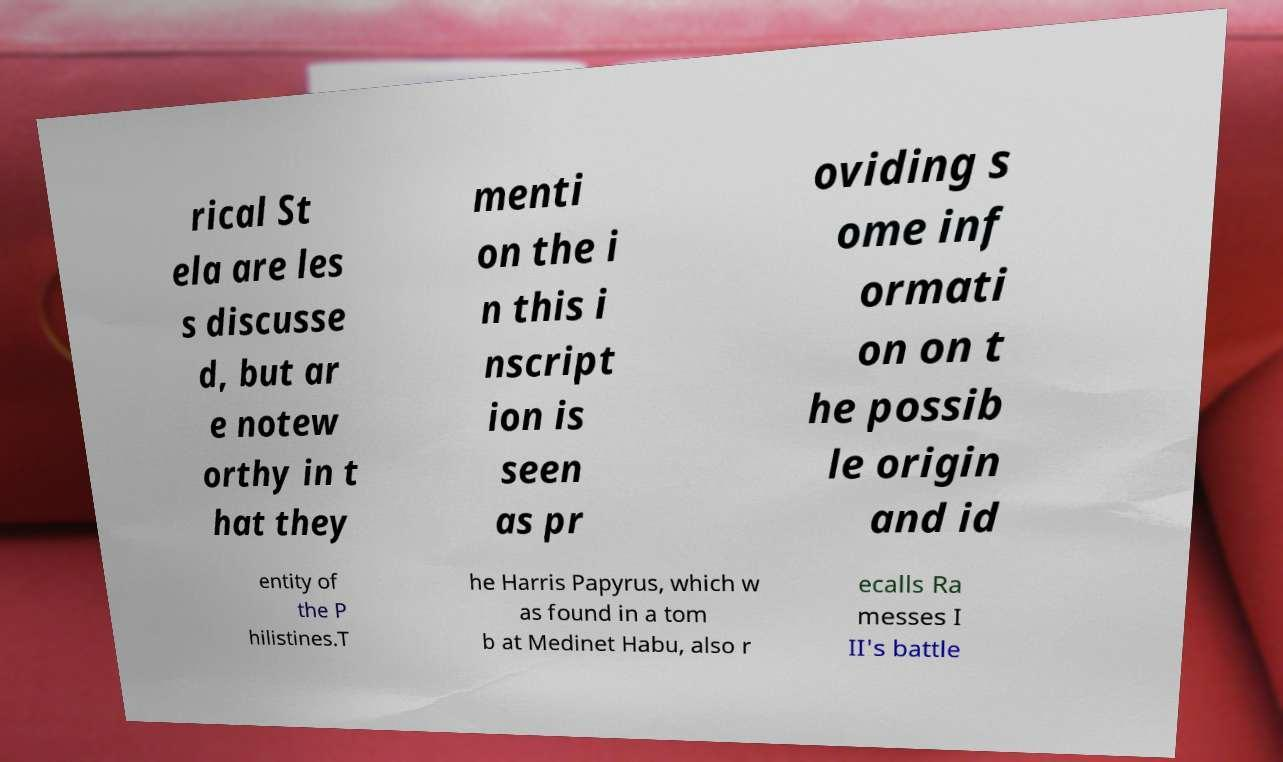For documentation purposes, I need the text within this image transcribed. Could you provide that? rical St ela are les s discusse d, but ar e notew orthy in t hat they menti on the i n this i nscript ion is seen as pr oviding s ome inf ormati on on t he possib le origin and id entity of the P hilistines.T he Harris Papyrus, which w as found in a tom b at Medinet Habu, also r ecalls Ra messes I II's battle 